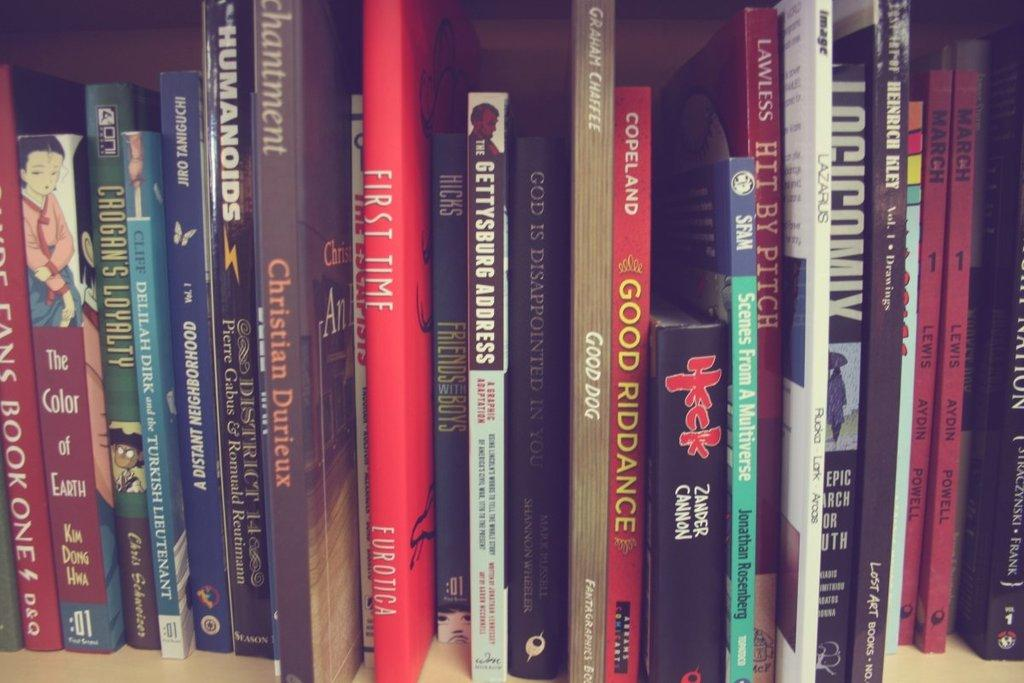<image>
Relay a brief, clear account of the picture shown. One of the many books on the shelf is "Good Riddance". 